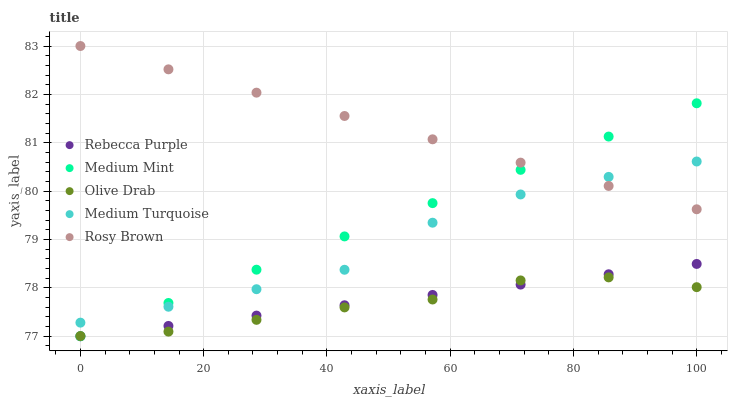Does Olive Drab have the minimum area under the curve?
Answer yes or no. Yes. Does Rosy Brown have the maximum area under the curve?
Answer yes or no. Yes. Does Medium Turquoise have the minimum area under the curve?
Answer yes or no. No. Does Medium Turquoise have the maximum area under the curve?
Answer yes or no. No. Is Rebecca Purple the smoothest?
Answer yes or no. Yes. Is Medium Turquoise the roughest?
Answer yes or no. Yes. Is Rosy Brown the smoothest?
Answer yes or no. No. Is Rosy Brown the roughest?
Answer yes or no. No. Does Medium Mint have the lowest value?
Answer yes or no. Yes. Does Medium Turquoise have the lowest value?
Answer yes or no. No. Does Rosy Brown have the highest value?
Answer yes or no. Yes. Does Medium Turquoise have the highest value?
Answer yes or no. No. Is Olive Drab less than Medium Turquoise?
Answer yes or no. Yes. Is Medium Turquoise greater than Rebecca Purple?
Answer yes or no. Yes. Does Medium Mint intersect Medium Turquoise?
Answer yes or no. Yes. Is Medium Mint less than Medium Turquoise?
Answer yes or no. No. Is Medium Mint greater than Medium Turquoise?
Answer yes or no. No. Does Olive Drab intersect Medium Turquoise?
Answer yes or no. No. 